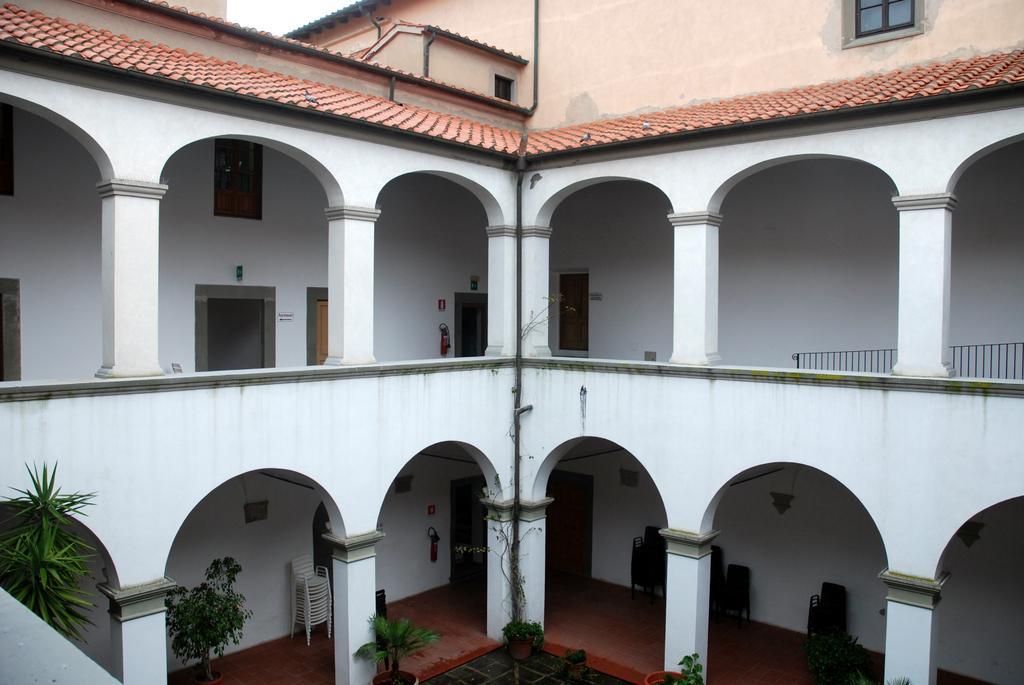Could you give a brief overview of what you see in this image? In this image we can see a building, there are doors, windows, plants, trees, chairs, pillars, and walls. 